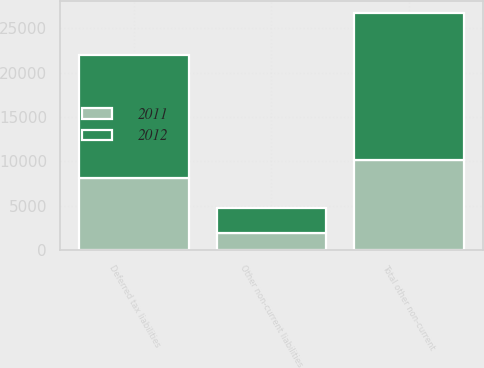<chart> <loc_0><loc_0><loc_500><loc_500><stacked_bar_chart><ecel><fcel>Deferred tax liabilities<fcel>Other non-current liabilities<fcel>Total other non-current<nl><fcel>2012<fcel>13847<fcel>2817<fcel>16664<nl><fcel>2011<fcel>8159<fcel>1941<fcel>10100<nl></chart> 